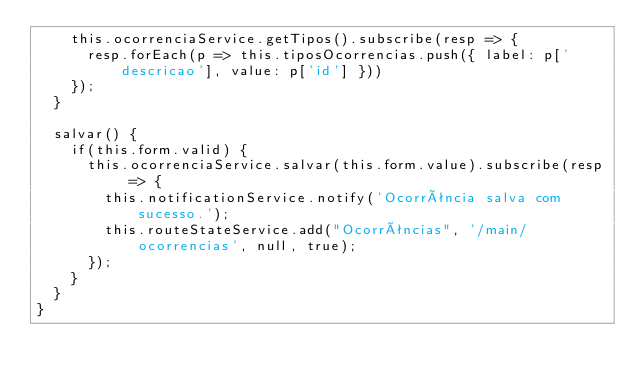Convert code to text. <code><loc_0><loc_0><loc_500><loc_500><_TypeScript_>    this.ocorrenciaService.getTipos().subscribe(resp => {
      resp.forEach(p => this.tiposOcorrencias.push({ label: p['descricao'], value: p['id'] }))
    });
  }

  salvar() {
    if(this.form.valid) {
      this.ocorrenciaService.salvar(this.form.value).subscribe(resp => {
        this.notificationService.notify('Ocorrência salva com sucesso.');
        this.routeStateService.add("Ocorrências", '/main/ocorrencias', null, true);
      });
    }
  }
}
</code> 